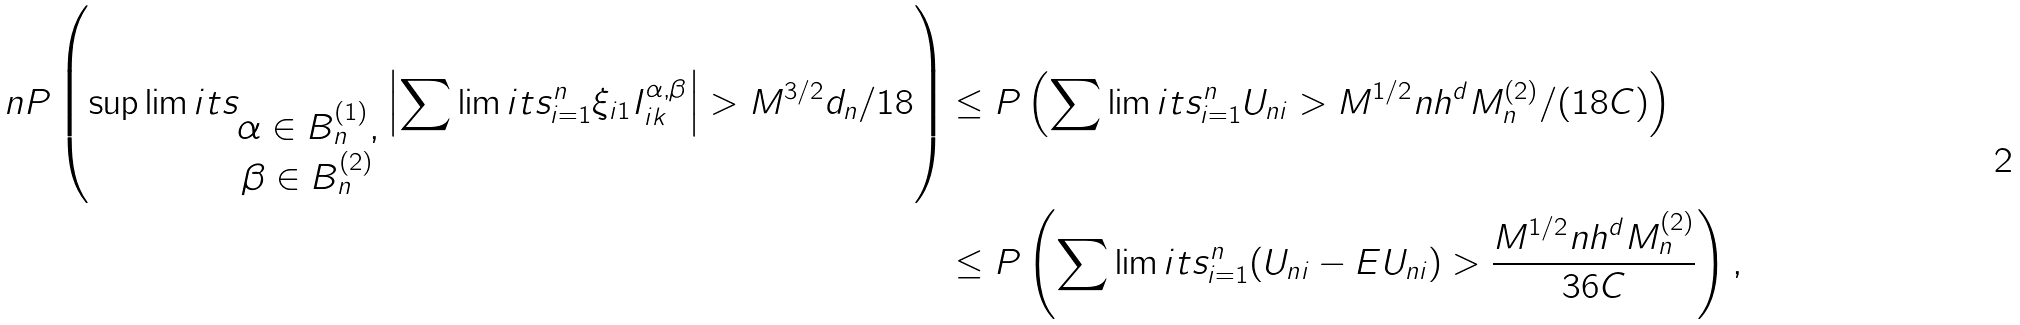<formula> <loc_0><loc_0><loc_500><loc_500>\ n P \left ( \sup \lim i t s _ { \begin{matrix} \alpha \in B _ { n } ^ { ( 1 ) } , \\ \beta \in B _ { n } ^ { ( 2 ) } \end{matrix} } \left | \sum \lim i t s _ { i = 1 } ^ { n } \xi _ { i 1 } I ^ { \alpha , \beta } _ { i k } \right | > M ^ { 3 / 2 } d _ { n } / 1 8 \right ) & \leq P \left ( \sum \lim i t s _ { i = 1 } ^ { n } U _ { n i } > M ^ { 1 / 2 } n h ^ { d } M _ { n } ^ { ( 2 ) } / ( 1 8 C ) \right ) \\ & \leq P \left ( \sum \lim i t s _ { i = 1 } ^ { n } ( U _ { n i } - E U _ { n i } ) > \frac { M ^ { 1 / 2 } n h ^ { d } M _ { n } ^ { ( 2 ) } } { 3 6 C } \right ) ,</formula> 